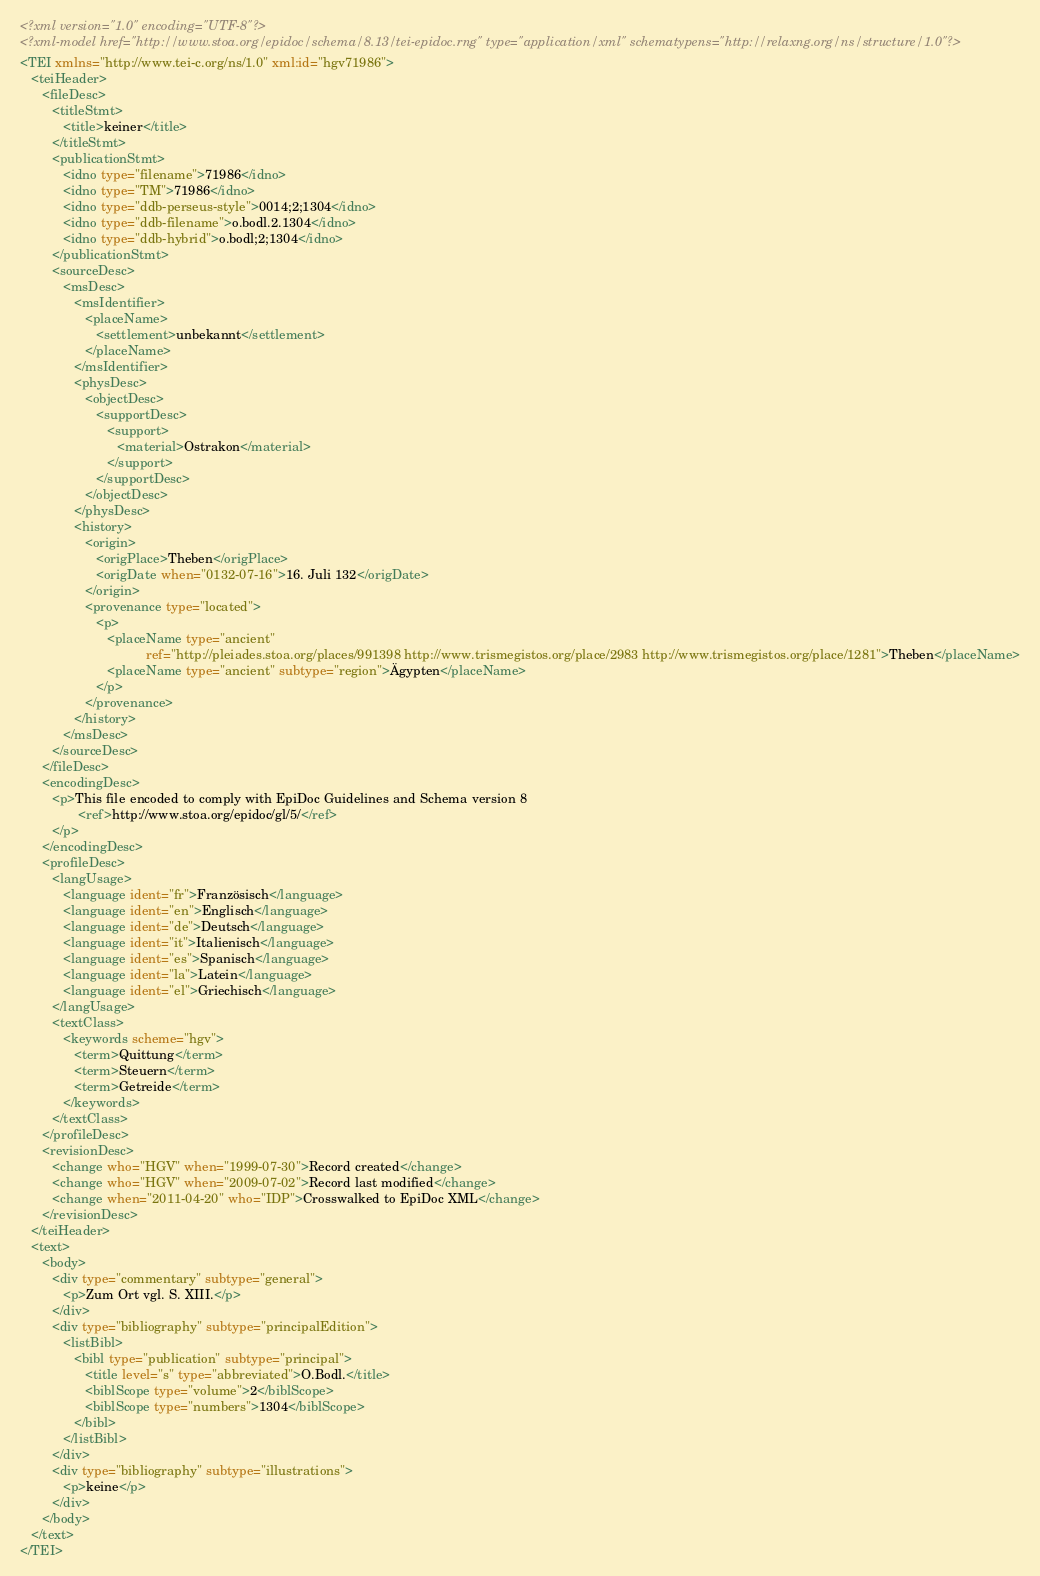<code> <loc_0><loc_0><loc_500><loc_500><_XML_><?xml version="1.0" encoding="UTF-8"?>
<?xml-model href="http://www.stoa.org/epidoc/schema/8.13/tei-epidoc.rng" type="application/xml" schematypens="http://relaxng.org/ns/structure/1.0"?>
<TEI xmlns="http://www.tei-c.org/ns/1.0" xml:id="hgv71986">
   <teiHeader>
      <fileDesc>
         <titleStmt>
            <title>keiner</title>
         </titleStmt>
         <publicationStmt>
            <idno type="filename">71986</idno>
            <idno type="TM">71986</idno>
            <idno type="ddb-perseus-style">0014;2;1304</idno>
            <idno type="ddb-filename">o.bodl.2.1304</idno>
            <idno type="ddb-hybrid">o.bodl;2;1304</idno>
         </publicationStmt>
         <sourceDesc>
            <msDesc>
               <msIdentifier>
                  <placeName>
                     <settlement>unbekannt</settlement>
                  </placeName>
               </msIdentifier>
               <physDesc>
                  <objectDesc>
                     <supportDesc>
                        <support>
                           <material>Ostrakon</material>
                        </support>
                     </supportDesc>
                  </objectDesc>
               </physDesc>
               <history>
                  <origin>
                     <origPlace>Theben</origPlace>
                     <origDate when="0132-07-16">16. Juli 132</origDate>
                  </origin>
                  <provenance type="located">
                     <p>
                        <placeName type="ancient"
                                   ref="http://pleiades.stoa.org/places/991398 http://www.trismegistos.org/place/2983 http://www.trismegistos.org/place/1281">Theben</placeName>
                        <placeName type="ancient" subtype="region">Ägypten</placeName>
                     </p>
                  </provenance>
               </history>
            </msDesc>
         </sourceDesc>
      </fileDesc>
      <encodingDesc>
         <p>This file encoded to comply with EpiDoc Guidelines and Schema version 8
                <ref>http://www.stoa.org/epidoc/gl/5/</ref>
         </p>
      </encodingDesc>
      <profileDesc>
         <langUsage>
            <language ident="fr">Französisch</language>
            <language ident="en">Englisch</language>
            <language ident="de">Deutsch</language>
            <language ident="it">Italienisch</language>
            <language ident="es">Spanisch</language>
            <language ident="la">Latein</language>
            <language ident="el">Griechisch</language>
         </langUsage>
         <textClass>
            <keywords scheme="hgv">
               <term>Quittung</term>
               <term>Steuern</term>
               <term>Getreide</term>
            </keywords>
         </textClass>
      </profileDesc>
      <revisionDesc>
         <change who="HGV" when="1999-07-30">Record created</change>
         <change who="HGV" when="2009-07-02">Record last modified</change>
         <change when="2011-04-20" who="IDP">Crosswalked to EpiDoc XML</change>
      </revisionDesc>
   </teiHeader>
   <text>
      <body>
         <div type="commentary" subtype="general">
            <p>Zum Ort vgl. S. XIII.</p>
         </div>
         <div type="bibliography" subtype="principalEdition">
            <listBibl>
               <bibl type="publication" subtype="principal">
                  <title level="s" type="abbreviated">O.Bodl.</title>
                  <biblScope type="volume">2</biblScope>
                  <biblScope type="numbers">1304</biblScope>
               </bibl>
            </listBibl>
         </div>
         <div type="bibliography" subtype="illustrations">
            <p>keine</p>
         </div>
      </body>
   </text>
</TEI>
</code> 